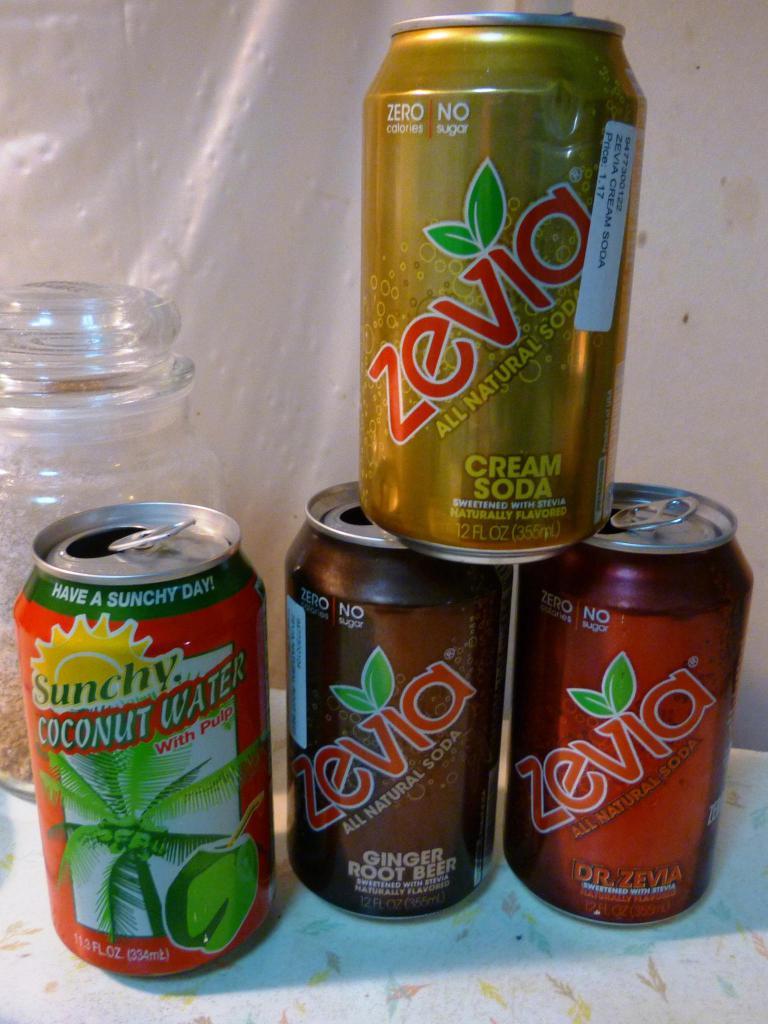What brand of soda is depicted?
Give a very brief answer. Zevia. What kind of water is in the can on the left?
Ensure brevity in your answer.  Coconut. 